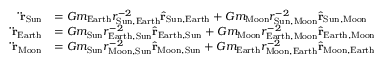Convert formula to latex. <formula><loc_0><loc_0><loc_500><loc_500>{ \begin{array} { r l } { \ddot { r } _ { S u n } } & { = G m _ { E a r t h } r _ { { S u n } , { E a r t h } } ^ { - 2 } { \hat { r } } _ { { S u n } , { E a r t h } } + G m _ { M o o n } r _ { { S u n } , { M o o n } } ^ { - 2 } { \hat { r } } _ { { S u n } , { M o o n } } } \\ { \ddot { r } _ { E a r t h } } & { = G m _ { S u n } r _ { { E a r t h } , { S u n } } ^ { - 2 } { \hat { r } } _ { { E a r t h } , { S u n } } + G m _ { M o o n } r _ { { E a r t h } , { M o o n } } ^ { - 2 } { \hat { r } } _ { { E a r t h } , { M o o n } } } \\ { \ddot { r } _ { M o o n } } & { = G m _ { S u n } r _ { { M o o n } , { S u n } } ^ { - 2 } { \hat { r } } _ { { M o o n } , { S u n } } + G m _ { E a r t h } r _ { { M o o n } , { E a r t h } } ^ { - 2 } { \hat { r } } _ { { M o o n } , { E a r t h } } } \end{array} }</formula> 